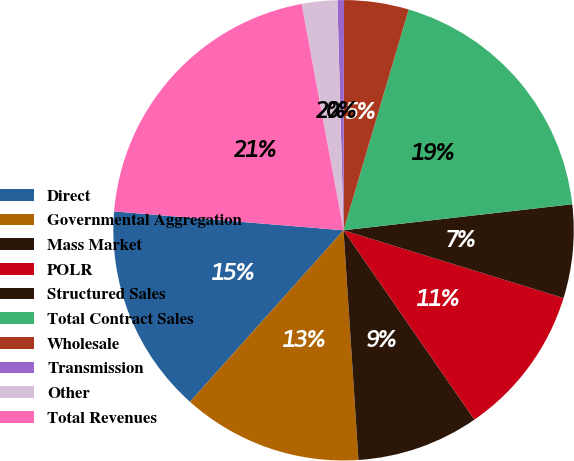<chart> <loc_0><loc_0><loc_500><loc_500><pie_chart><fcel>Direct<fcel>Governmental Aggregation<fcel>Mass Market<fcel>POLR<fcel>Structured Sales<fcel>Total Contract Sales<fcel>Wholesale<fcel>Transmission<fcel>Other<fcel>Total Revenues<nl><fcel>14.69%<fcel>12.65%<fcel>8.59%<fcel>10.62%<fcel>6.56%<fcel>18.63%<fcel>4.53%<fcel>0.46%<fcel>2.49%<fcel>20.78%<nl></chart> 